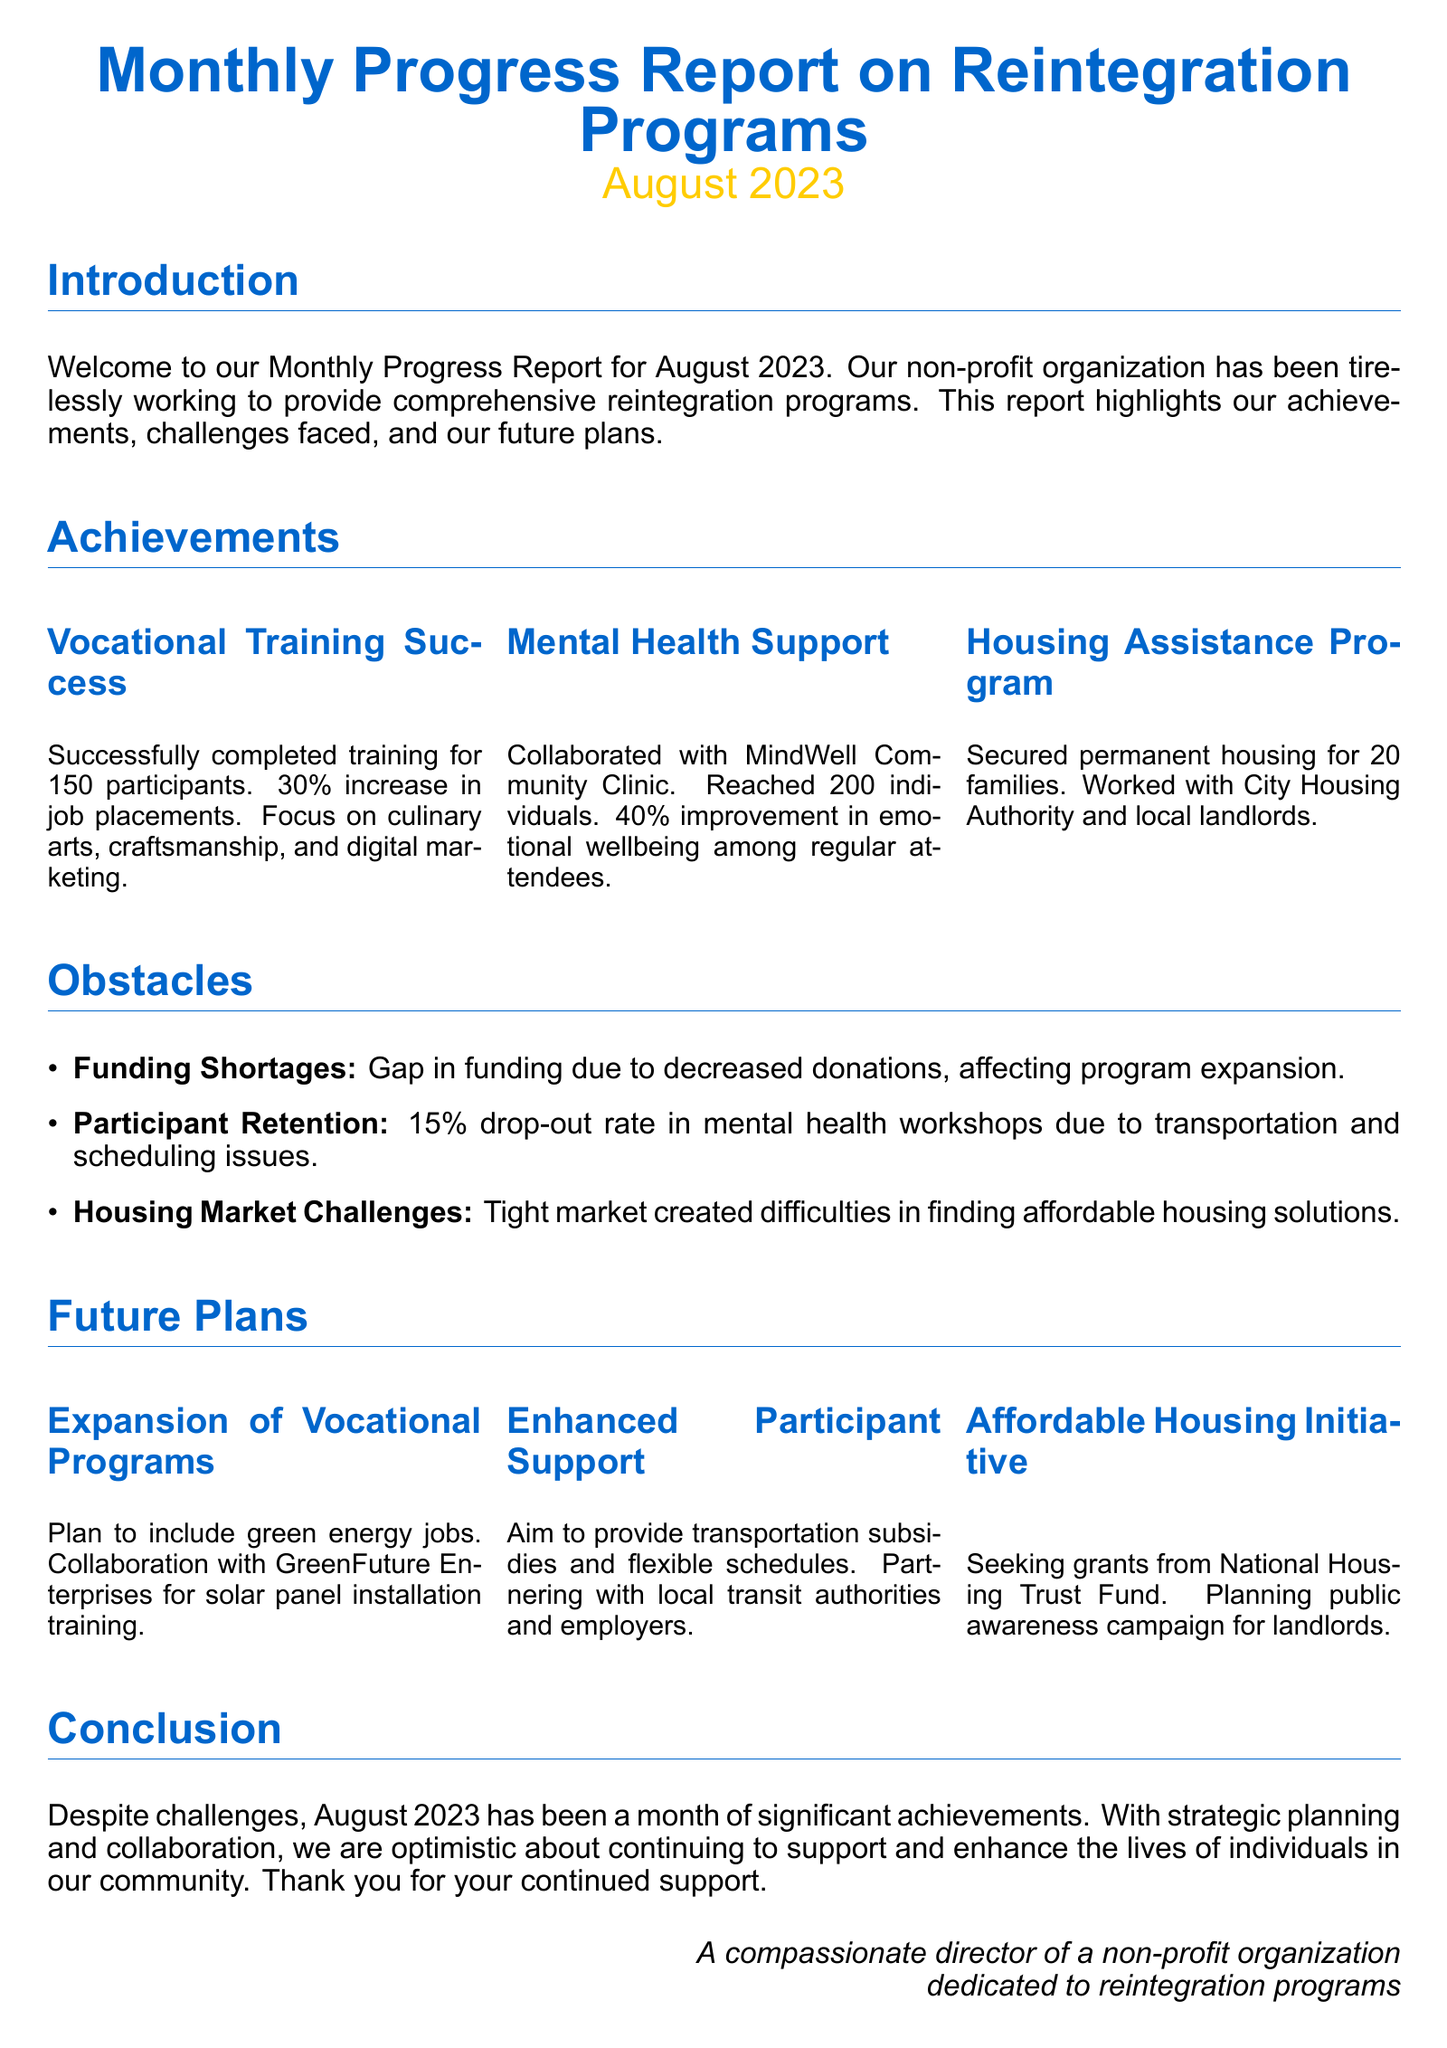What was the percentage increase in job placements? The document states there was a 30% increase in job placements as a result of vocational training programs.
Answer: 30% How many individuals received mental health support? The report indicates that 200 individuals were reached through mental health support initiatives.
Answer: 200 What is the drop-out rate for mental health workshops? The document mentions a 15% drop-out rate for participants in mental health workshops due to various issues.
Answer: 15% How many families secured permanent housing? According to the report, permanent housing was secured for 20 families through the housing assistance program.
Answer: 20 What future initiative involves training for solar panel installation? The document refers to a plan to include green energy jobs in collaboration with GreenFuture Enterprises for training in solar panel installation.
Answer: Solar panel installation What was one of the main obstacles faced in the housing market? The document highlights that the tight housing market created difficulties in finding affordable housing solutions.
Answer: Tight market Which organization did the mental health support program collaborate with? The report specifies that the mental health support program collaborated with MindWell Community Clinic.
Answer: MindWell Community Clinic What is one of the plans for enhancing participant support? The future plans include providing transportation subsidies and flexible schedules to improve participant support.
Answer: Transportation subsidies What was a major consequence of funding shortages? The document notes that funding shortages affected the expansion of programs.
Answer: Program expansion 